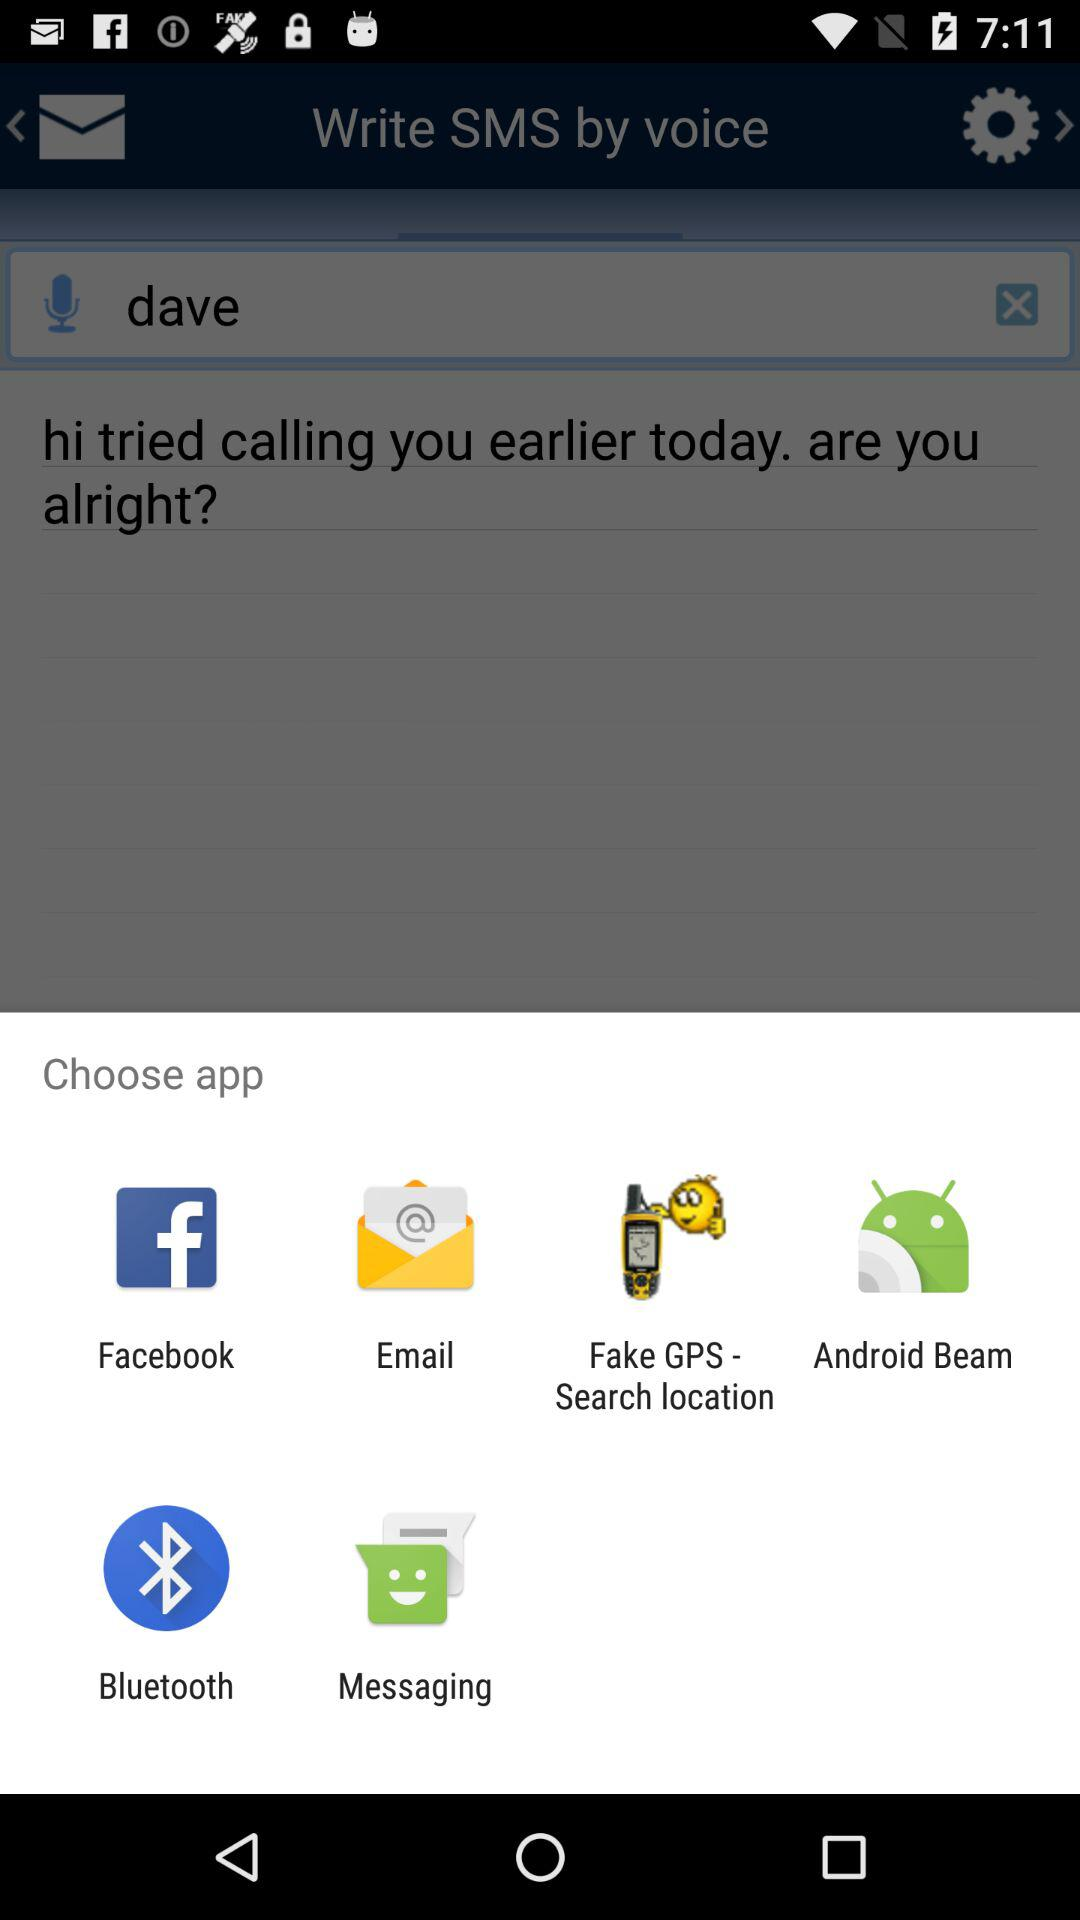What is the name of the application? The name of the application is "Write SMS by voice". 